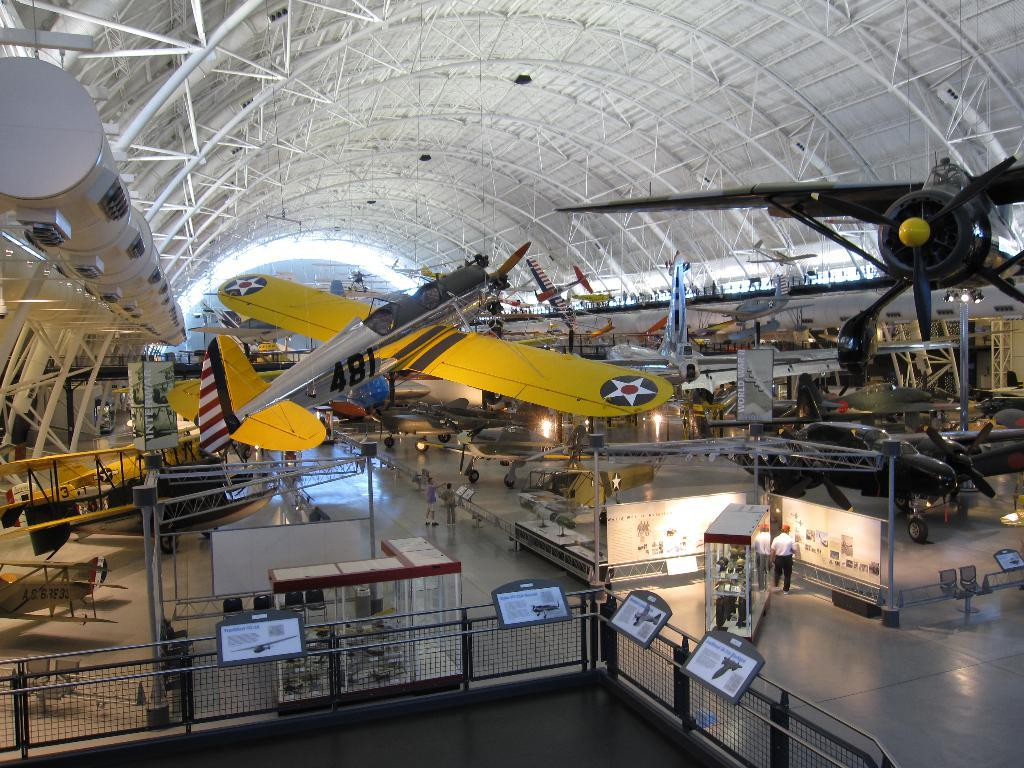What type of vehicles are under the shed in the image? There are airplanes under a shed in the image. Can you describe the people in the image? There are people standing in the image. What materials can be seen in the image? There are boards and poles in the image. What surface is visible in the image? There is a floor in the image. What provides illumination in the image? There are lights in the image. What type of furniture is present in the image? There are chairs in the image. What safety feature can be seen in the image? There is a railing in the image. Are there any other objects visible in the image? Yes, there are additional objects in the image. What type of tree is growing in the middle of the airplane in the image? There is no tree growing in the middle of the airplane in the image. What is the wing of the airplane used for in the image? The wing of the airplane is not used for anything in the image, as the airplanes are under a shed and not in flight. 